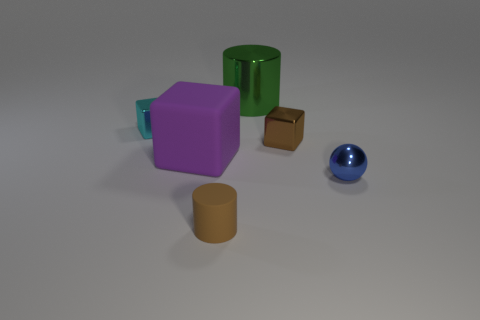Add 2 big brown blocks. How many objects exist? 8 Subtract all cylinders. How many objects are left? 4 Subtract all tiny brown things. Subtract all red metal things. How many objects are left? 4 Add 1 small brown things. How many small brown things are left? 3 Add 1 tiny metallic blocks. How many tiny metallic blocks exist? 3 Subtract 0 red cubes. How many objects are left? 6 